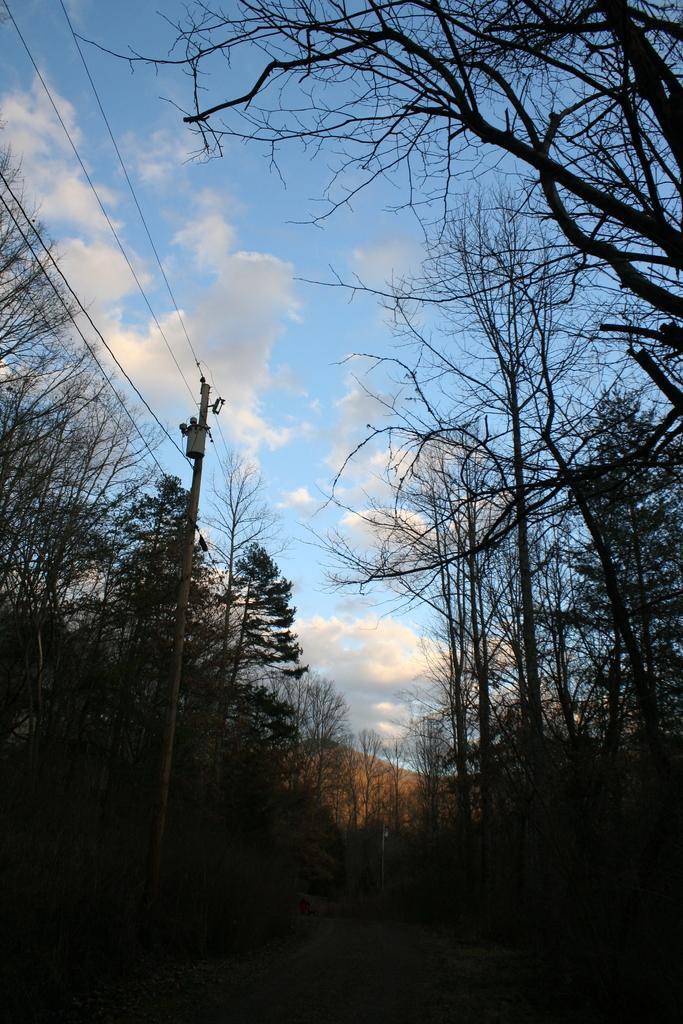Can you describe this image briefly? In this image we can see few trees, pole with wires and the sky with clouds in the background. 